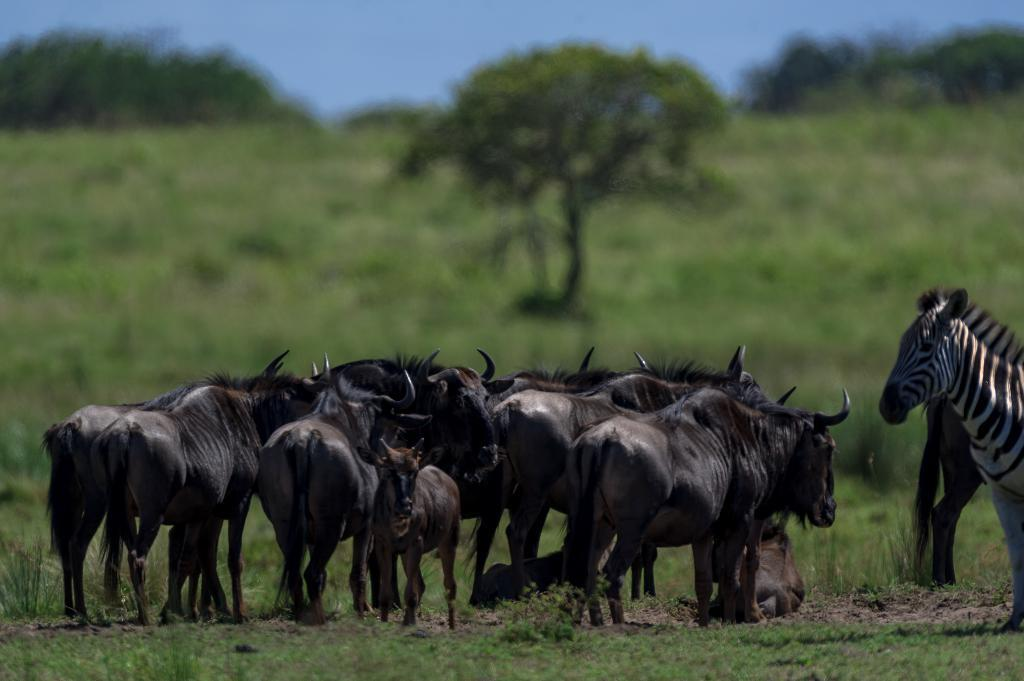What type of animals can be seen in the image? There is a herd of animals in the image, including a zebra. What is the terrain like where the animals are located? The animals are on the grass. What can be seen in front of the animals? There are trees in front of the animals. What is visible in the background of the image? The sky is visible in the image. What is the name of the governor of the animals in the image? There is no governor mentioned or implied in the image, as it features a herd of animals in a natural setting. 